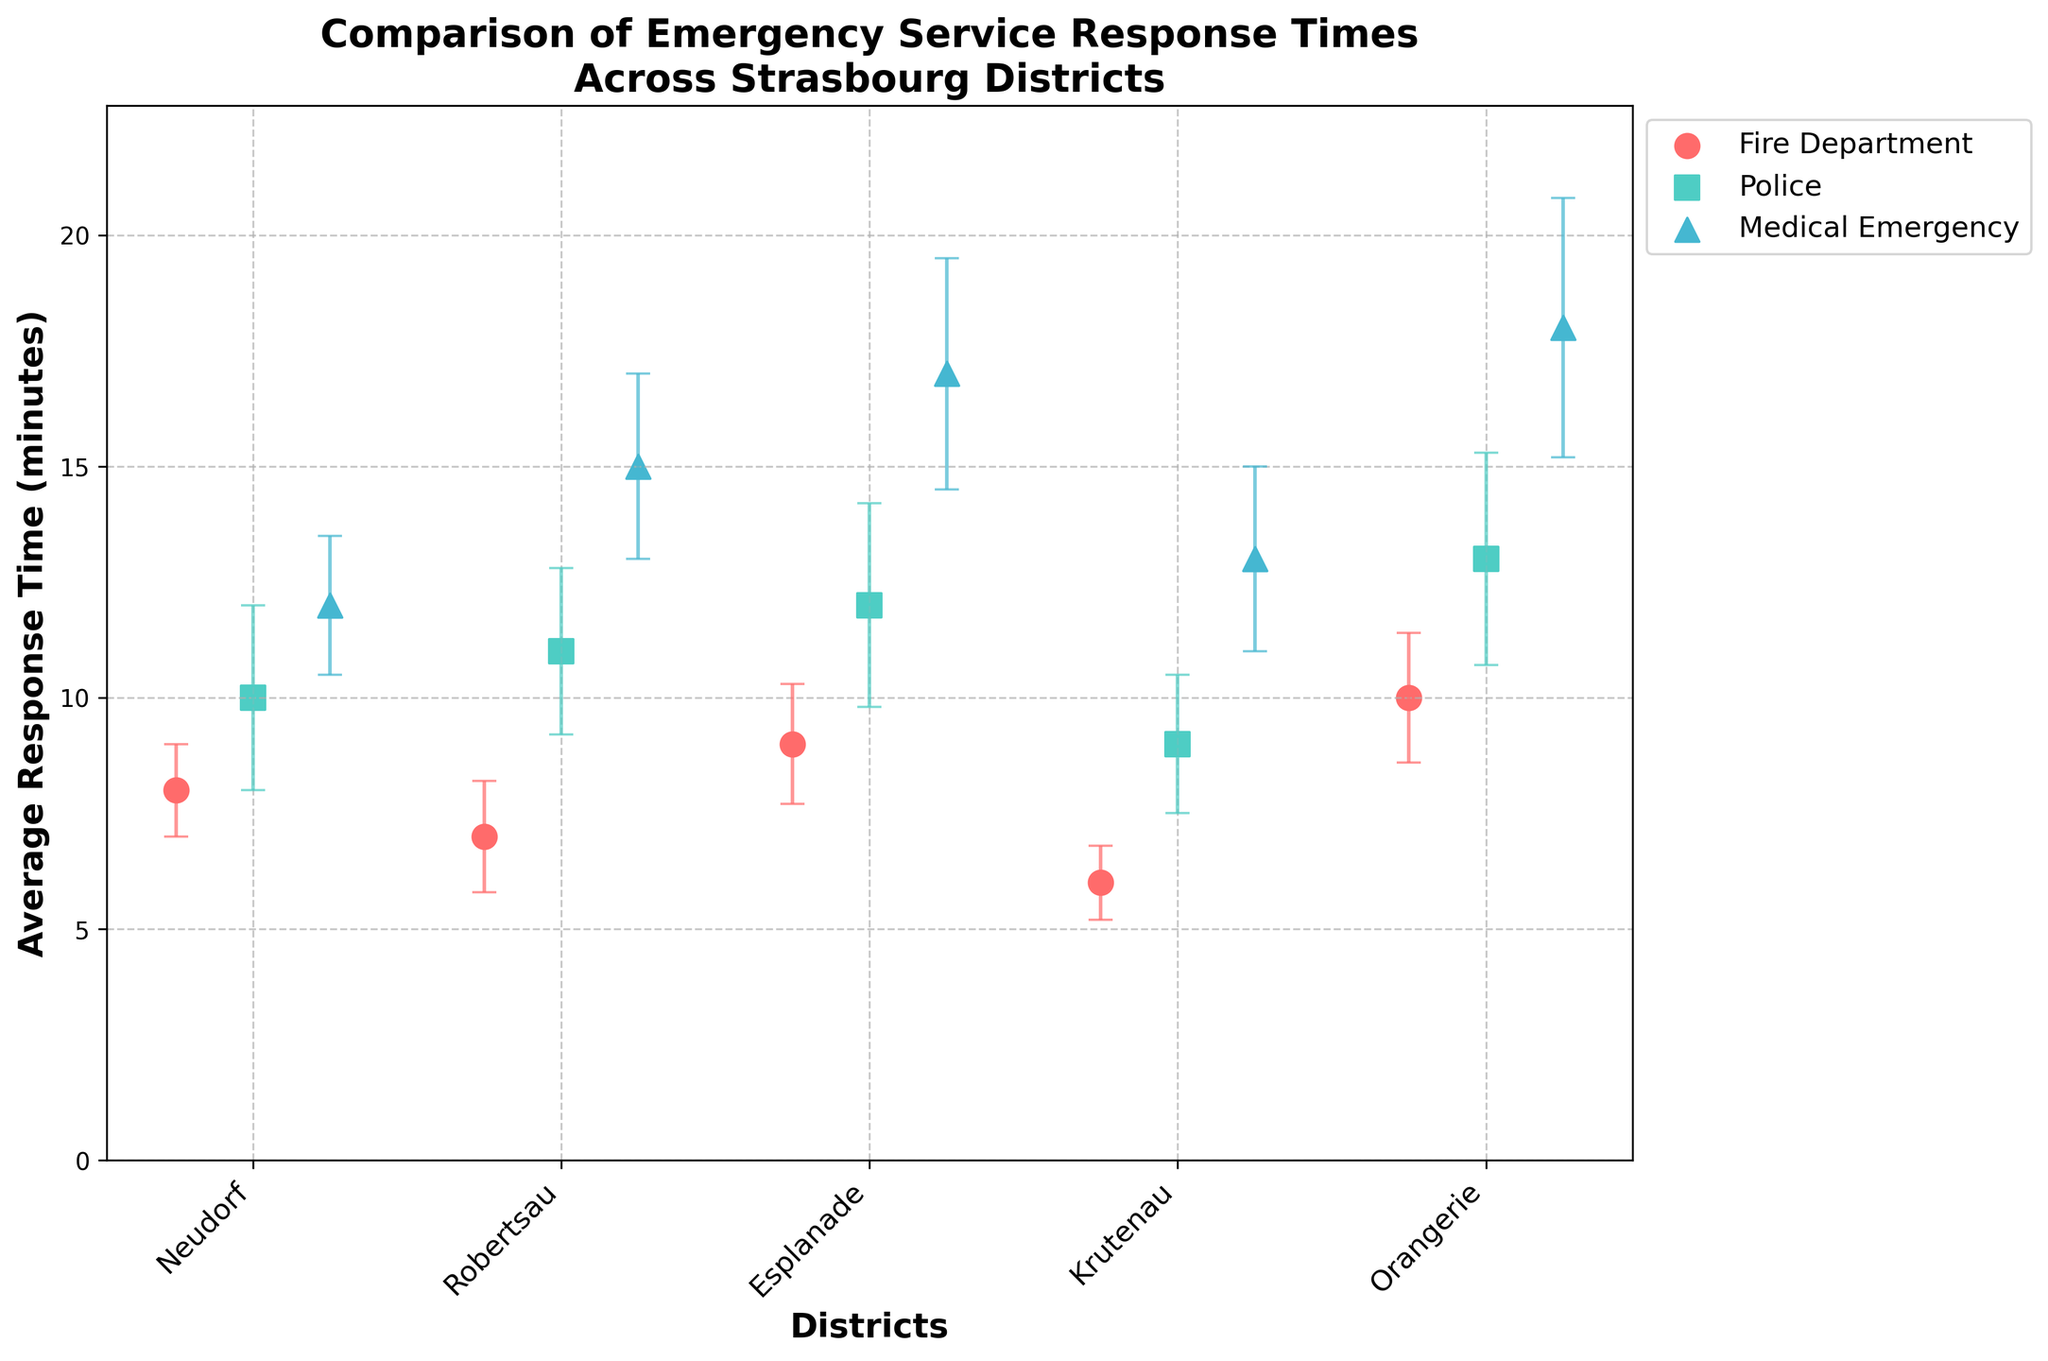What are the average response times for Medical Emergency services in different districts? To find this information, look at the Medical Emergency service data points along with their corresponding districts. For Neudorf: 12 minutes, for Robertsau: 15 minutes, for Esplanade: 17 minutes, for Krutenau: 13 minutes, and for Orangerie: 18 minutes.
Answer: Neudorf: 12, Robertsau: 15, Esplanade: 17, Krutenau: 13, Orangerie: 18 minutes What district has the shortest average response time for Fire Department services? To determine this, check the data points for the Fire Department across all districts. The district with the lowest value is Krutenau with an average response time of 6 minutes.
Answer: Krutenau Which emergency service in Orangerie has the highest average response time? For Orangerie, compare the average response times of the three emergency services. The Medical Emergency service has the highest average response time at 18 minutes.
Answer: Medical Emergency What's the average of the average response times for Police services across all districts? Extract the average response times for Police services in all districts: 10 (Neudorf), 11 (Robertsau), 12 (Esplanade), 9 (Krutenau), and 13 (Orangerie). Sum these times (10 + 11 + 12 + 9 + 13 = 55) and then divide by the number of districts (55 / 5 = 11).
Answer: 11 minutes Which district has the greatest variability in response times among different emergency services? Evaluate the range of response times within each district. The greatest range can be found in Orangerie with a variance from 10 (Fire Department) to 18 (Medical Emergency).
Answer: Orangerie How do the average response times for Fire Department compare to Medical Emergency services in Esplanade? Compare the provided average response times: Fire Department in Esplanade is 9 minutes, Medical Emergency is 17 minutes. The Fire Department responds faster by 8 minutes.
Answer: Fire Department is faster by 8 minutes What is the margin of error for Medical Emergency services in Robertsau? Look at the error bar data for Medical Emergency services in Robertsau, which is given as 2 minutes.
Answer: 2 minutes Which emergency service in Krutenau shows the smallest margin of error? Compare the error bars for all emergency services in Krutenau. The Fire Department has the smallest margin of error at 0.8 minutes.
Answer: Fire Department What is the difference in average response times between the Police services in Neudorf and Orangerie? Extract the average response times: Police in Neudorf is 10 minutes, in Orangerie is 13 minutes. Subtract the Neudorf time from the Orangerie time (13 - 10 = 3).
Answer: 3 minutes 